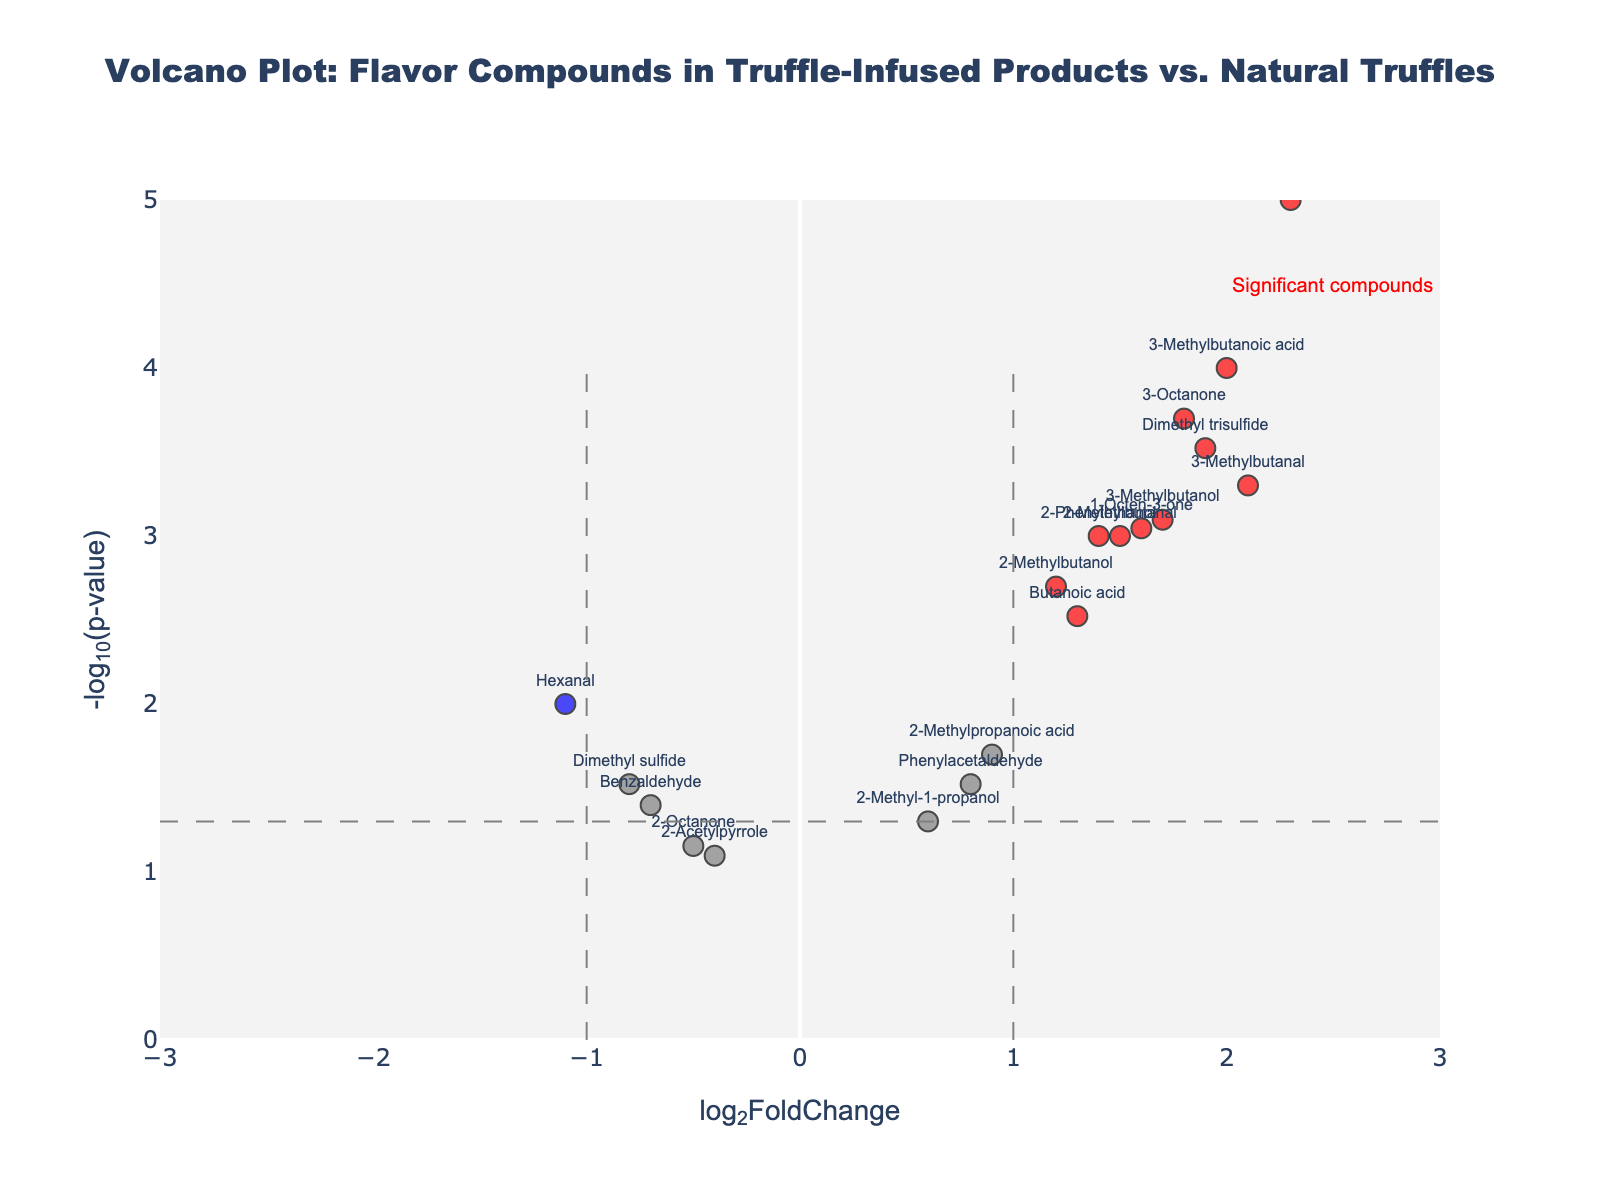What is the title of the plot? The title of the plot is displayed at the top of the figure. It reads: "Volcano Plot: Flavor Compounds in Truffle-Infused Products vs. Natural Truffles".
Answer: Volcano Plot: Flavor Compounds in Truffle-Infused Products vs. Natural Truffles What are the x-axis and y-axis labels? The x-axis label is "log2FoldChange" and the y-axis label is "-log10(p-value)". These are shown on the respective axes of the plot.
Answer: log2FoldChange and -log10(p-value) How many compounds are shown in the plot? Each compound in the dataset is represented as a point in the plot. By counting the number of data points (markers), we can determine that there are 20 compounds shown.
Answer: 20 Which compound has the highest log2FoldChange? In the plot, the compound with the highest log2FoldChange is the one farthest to the right on the x-axis. This is "Bis(methylthio)methane" with a log2FoldChange of 2.5.
Answer: Bis(methylthio)methane What color indicates significant compounds with an increase in log2FoldChange? Significant compounds with an increase in log2FoldChange are colored red in the plot.
Answer: Red How many significant compounds are there in total? Significant compounds are those either red or blue. Count the number of red or blue data points. There are 12 significant compounds in total.
Answer: 12 Which compound is most statistically significant? The compound with the lowest p-value is the most statistically significant, shown as the highest point on the y-axis. This is "1-Octen-3-ol" with a -log10(p-value) value around 5.
Answer: 1-Octen-3-ol Which significant compounds are downregulated (negative log2FoldChange)? Significant downregulated compounds have a log2FoldChange less than -1 and are colored blue. The compounds are "Hexanal" and "Dimethyl sulfide".
Answer: Hexanal and Dimethyl sulfide Between "3-Methylbutanal" and "3-Octanone," which compound is more statistically significant? Compare the -log10(p-value) values of both compounds. "3-Methylbutanal" is more statistically significant since it has a higher -log10(p-value) value than "3-Octanone".
Answer: 3-Methylbutanal 